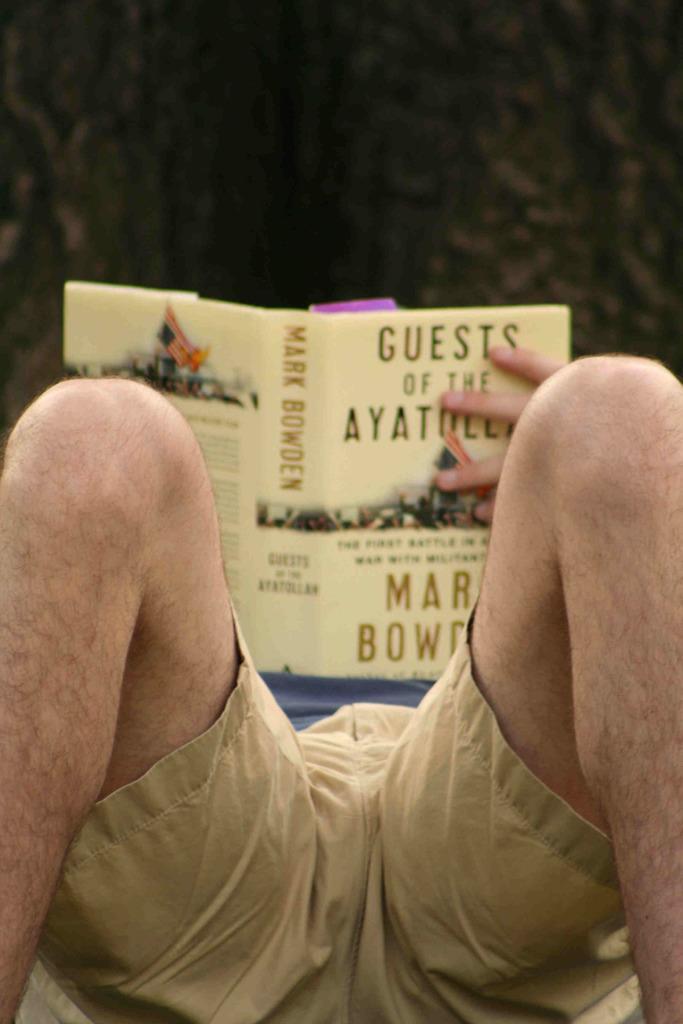Could you give a brief overview of what you see in this image? In this picture we can see a man, he is holding a book and we can see blurry background. 